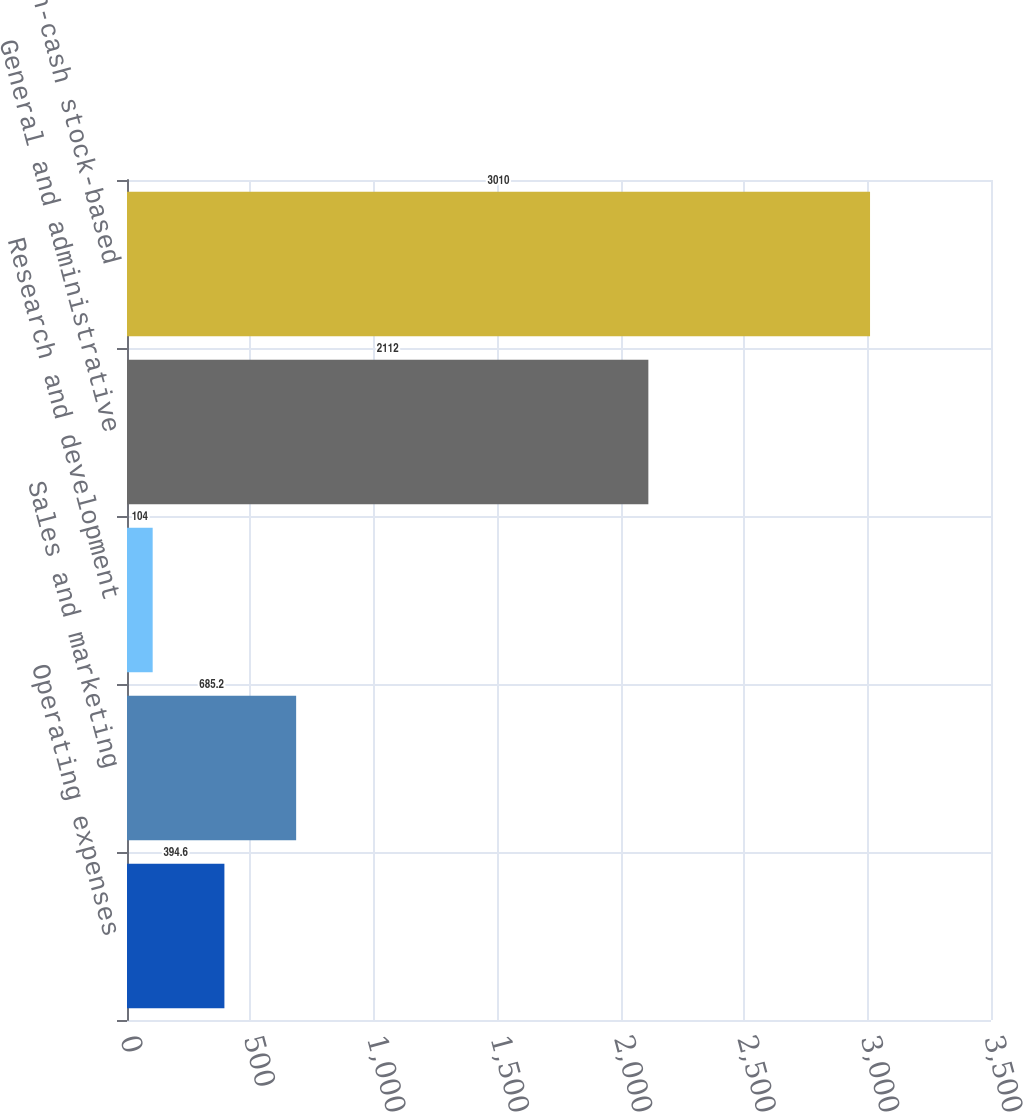Convert chart to OTSL. <chart><loc_0><loc_0><loc_500><loc_500><bar_chart><fcel>Operating expenses<fcel>Sales and marketing<fcel>Research and development<fcel>General and administrative<fcel>Total non-cash stock-based<nl><fcel>394.6<fcel>685.2<fcel>104<fcel>2112<fcel>3010<nl></chart> 